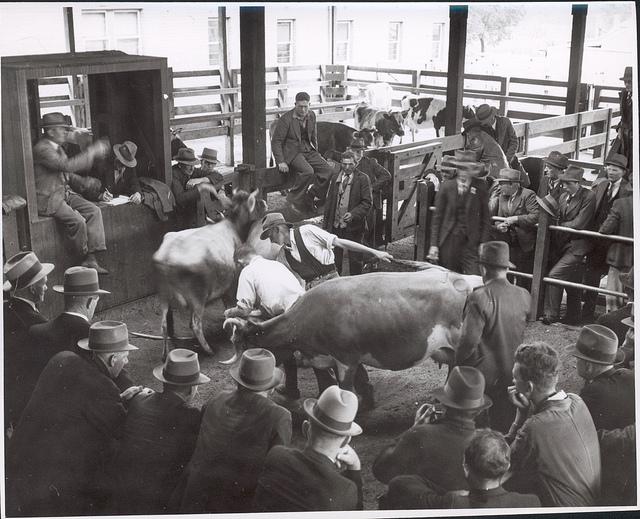How many animals in the shot?
Keep it brief. 4. Are any of them men wearing hats?
Keep it brief. Yes. Did this happen recently?
Be succinct. No. What type of animals?
Answer briefly. Cows. 